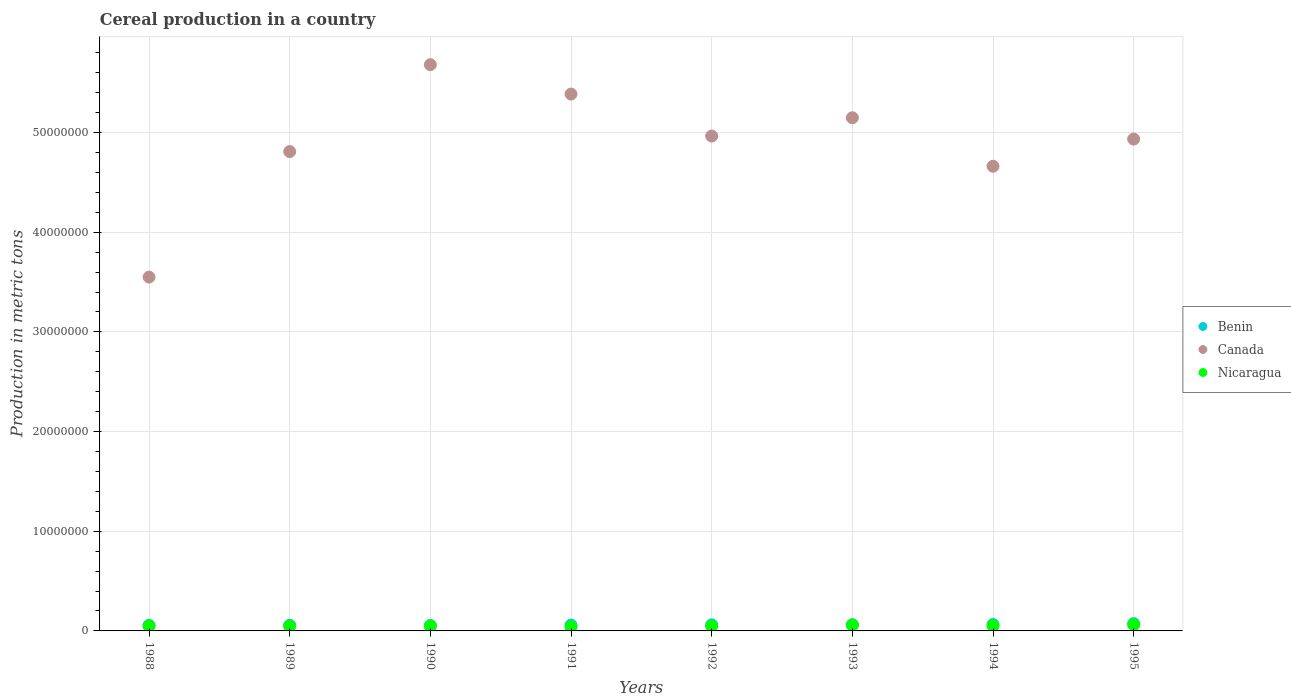How many different coloured dotlines are there?
Provide a short and direct response. 3. Is the number of dotlines equal to the number of legend labels?
Offer a very short reply. Yes. What is the total cereal production in Benin in 1994?
Keep it short and to the point. 6.45e+05. Across all years, what is the maximum total cereal production in Nicaragua?
Your response must be concise. 6.22e+05. Across all years, what is the minimum total cereal production in Benin?
Ensure brevity in your answer.  5.46e+05. In which year was the total cereal production in Benin maximum?
Ensure brevity in your answer.  1995. What is the total total cereal production in Canada in the graph?
Your answer should be compact. 3.91e+08. What is the difference between the total cereal production in Canada in 1990 and that in 1991?
Provide a succinct answer. 2.95e+06. What is the difference between the total cereal production in Nicaragua in 1988 and the total cereal production in Benin in 1995?
Ensure brevity in your answer.  -2.29e+05. What is the average total cereal production in Nicaragua per year?
Your answer should be very brief. 5.13e+05. In the year 1992, what is the difference between the total cereal production in Canada and total cereal production in Nicaragua?
Offer a very short reply. 4.91e+07. In how many years, is the total cereal production in Canada greater than 34000000 metric tons?
Your answer should be compact. 8. What is the ratio of the total cereal production in Canada in 1988 to that in 1995?
Offer a very short reply. 0.72. Is the total cereal production in Nicaragua in 1988 less than that in 1992?
Keep it short and to the point. No. What is the difference between the highest and the second highest total cereal production in Canada?
Ensure brevity in your answer.  2.95e+06. What is the difference between the highest and the lowest total cereal production in Benin?
Keep it short and to the point. 1.88e+05. In how many years, is the total cereal production in Benin greater than the average total cereal production in Benin taken over all years?
Provide a succinct answer. 4. Is it the case that in every year, the sum of the total cereal production in Nicaragua and total cereal production in Benin  is greater than the total cereal production in Canada?
Offer a very short reply. No. Is the total cereal production in Canada strictly less than the total cereal production in Benin over the years?
Offer a very short reply. No. Are the values on the major ticks of Y-axis written in scientific E-notation?
Make the answer very short. No. Does the graph contain grids?
Ensure brevity in your answer.  Yes. How are the legend labels stacked?
Your answer should be compact. Vertical. What is the title of the graph?
Your answer should be very brief. Cereal production in a country. What is the label or title of the X-axis?
Your response must be concise. Years. What is the label or title of the Y-axis?
Provide a succinct answer. Production in metric tons. What is the Production in metric tons in Benin in 1988?
Make the answer very short. 5.57e+05. What is the Production in metric tons of Canada in 1988?
Your answer should be very brief. 3.55e+07. What is the Production in metric tons in Nicaragua in 1988?
Offer a terse response. 5.06e+05. What is the Production in metric tons in Benin in 1989?
Offer a terse response. 5.65e+05. What is the Production in metric tons in Canada in 1989?
Your response must be concise. 4.81e+07. What is the Production in metric tons in Nicaragua in 1989?
Your answer should be very brief. 4.84e+05. What is the Production in metric tons in Benin in 1990?
Offer a terse response. 5.46e+05. What is the Production in metric tons in Canada in 1990?
Ensure brevity in your answer.  5.68e+07. What is the Production in metric tons of Nicaragua in 1990?
Offer a very short reply. 4.88e+05. What is the Production in metric tons in Benin in 1991?
Offer a terse response. 5.87e+05. What is the Production in metric tons of Canada in 1991?
Your answer should be very brief. 5.39e+07. What is the Production in metric tons in Nicaragua in 1991?
Make the answer very short. 4.01e+05. What is the Production in metric tons in Benin in 1992?
Make the answer very short. 6.09e+05. What is the Production in metric tons in Canada in 1992?
Keep it short and to the point. 4.96e+07. What is the Production in metric tons of Nicaragua in 1992?
Provide a succinct answer. 4.98e+05. What is the Production in metric tons of Benin in 1993?
Your answer should be very brief. 6.25e+05. What is the Production in metric tons of Canada in 1993?
Make the answer very short. 5.15e+07. What is the Production in metric tons in Nicaragua in 1993?
Ensure brevity in your answer.  5.88e+05. What is the Production in metric tons of Benin in 1994?
Keep it short and to the point. 6.45e+05. What is the Production in metric tons in Canada in 1994?
Your response must be concise. 4.66e+07. What is the Production in metric tons of Nicaragua in 1994?
Your response must be concise. 5.21e+05. What is the Production in metric tons in Benin in 1995?
Your answer should be very brief. 7.34e+05. What is the Production in metric tons in Canada in 1995?
Provide a short and direct response. 4.93e+07. What is the Production in metric tons in Nicaragua in 1995?
Provide a succinct answer. 6.22e+05. Across all years, what is the maximum Production in metric tons of Benin?
Your response must be concise. 7.34e+05. Across all years, what is the maximum Production in metric tons of Canada?
Your answer should be compact. 5.68e+07. Across all years, what is the maximum Production in metric tons of Nicaragua?
Offer a very short reply. 6.22e+05. Across all years, what is the minimum Production in metric tons in Benin?
Your answer should be very brief. 5.46e+05. Across all years, what is the minimum Production in metric tons in Canada?
Your answer should be compact. 3.55e+07. Across all years, what is the minimum Production in metric tons of Nicaragua?
Your answer should be compact. 4.01e+05. What is the total Production in metric tons of Benin in the graph?
Make the answer very short. 4.87e+06. What is the total Production in metric tons of Canada in the graph?
Ensure brevity in your answer.  3.91e+08. What is the total Production in metric tons in Nicaragua in the graph?
Keep it short and to the point. 4.11e+06. What is the difference between the Production in metric tons of Benin in 1988 and that in 1989?
Offer a terse response. -8036. What is the difference between the Production in metric tons of Canada in 1988 and that in 1989?
Offer a very short reply. -1.26e+07. What is the difference between the Production in metric tons of Nicaragua in 1988 and that in 1989?
Keep it short and to the point. 2.16e+04. What is the difference between the Production in metric tons in Benin in 1988 and that in 1990?
Keep it short and to the point. 1.11e+04. What is the difference between the Production in metric tons of Canada in 1988 and that in 1990?
Provide a succinct answer. -2.13e+07. What is the difference between the Production in metric tons of Nicaragua in 1988 and that in 1990?
Keep it short and to the point. 1.78e+04. What is the difference between the Production in metric tons of Benin in 1988 and that in 1991?
Provide a succinct answer. -3.04e+04. What is the difference between the Production in metric tons of Canada in 1988 and that in 1991?
Make the answer very short. -1.84e+07. What is the difference between the Production in metric tons in Nicaragua in 1988 and that in 1991?
Offer a very short reply. 1.05e+05. What is the difference between the Production in metric tons in Benin in 1988 and that in 1992?
Ensure brevity in your answer.  -5.25e+04. What is the difference between the Production in metric tons in Canada in 1988 and that in 1992?
Ensure brevity in your answer.  -1.42e+07. What is the difference between the Production in metric tons of Nicaragua in 1988 and that in 1992?
Keep it short and to the point. 7410. What is the difference between the Production in metric tons of Benin in 1988 and that in 1993?
Provide a short and direct response. -6.83e+04. What is the difference between the Production in metric tons of Canada in 1988 and that in 1993?
Ensure brevity in your answer.  -1.60e+07. What is the difference between the Production in metric tons of Nicaragua in 1988 and that in 1993?
Your answer should be compact. -8.21e+04. What is the difference between the Production in metric tons in Benin in 1988 and that in 1994?
Offer a very short reply. -8.84e+04. What is the difference between the Production in metric tons in Canada in 1988 and that in 1994?
Offer a very short reply. -1.11e+07. What is the difference between the Production in metric tons of Nicaragua in 1988 and that in 1994?
Your response must be concise. -1.55e+04. What is the difference between the Production in metric tons in Benin in 1988 and that in 1995?
Your answer should be compact. -1.77e+05. What is the difference between the Production in metric tons of Canada in 1988 and that in 1995?
Offer a very short reply. -1.38e+07. What is the difference between the Production in metric tons in Nicaragua in 1988 and that in 1995?
Your answer should be compact. -1.16e+05. What is the difference between the Production in metric tons in Benin in 1989 and that in 1990?
Make the answer very short. 1.91e+04. What is the difference between the Production in metric tons of Canada in 1989 and that in 1990?
Your answer should be very brief. -8.72e+06. What is the difference between the Production in metric tons in Nicaragua in 1989 and that in 1990?
Your response must be concise. -3846. What is the difference between the Production in metric tons of Benin in 1989 and that in 1991?
Provide a short and direct response. -2.23e+04. What is the difference between the Production in metric tons of Canada in 1989 and that in 1991?
Keep it short and to the point. -5.77e+06. What is the difference between the Production in metric tons of Nicaragua in 1989 and that in 1991?
Provide a short and direct response. 8.34e+04. What is the difference between the Production in metric tons of Benin in 1989 and that in 1992?
Your answer should be compact. -4.45e+04. What is the difference between the Production in metric tons of Canada in 1989 and that in 1992?
Provide a short and direct response. -1.56e+06. What is the difference between the Production in metric tons in Nicaragua in 1989 and that in 1992?
Give a very brief answer. -1.42e+04. What is the difference between the Production in metric tons of Benin in 1989 and that in 1993?
Keep it short and to the point. -6.02e+04. What is the difference between the Production in metric tons in Canada in 1989 and that in 1993?
Your answer should be compact. -3.39e+06. What is the difference between the Production in metric tons of Nicaragua in 1989 and that in 1993?
Your answer should be very brief. -1.04e+05. What is the difference between the Production in metric tons in Benin in 1989 and that in 1994?
Your answer should be compact. -8.03e+04. What is the difference between the Production in metric tons of Canada in 1989 and that in 1994?
Keep it short and to the point. 1.47e+06. What is the difference between the Production in metric tons in Nicaragua in 1989 and that in 1994?
Provide a succinct answer. -3.71e+04. What is the difference between the Production in metric tons in Benin in 1989 and that in 1995?
Your answer should be very brief. -1.69e+05. What is the difference between the Production in metric tons in Canada in 1989 and that in 1995?
Provide a short and direct response. -1.25e+06. What is the difference between the Production in metric tons in Nicaragua in 1989 and that in 1995?
Make the answer very short. -1.38e+05. What is the difference between the Production in metric tons of Benin in 1990 and that in 1991?
Offer a very short reply. -4.14e+04. What is the difference between the Production in metric tons of Canada in 1990 and that in 1991?
Keep it short and to the point. 2.95e+06. What is the difference between the Production in metric tons in Nicaragua in 1990 and that in 1991?
Offer a very short reply. 8.72e+04. What is the difference between the Production in metric tons in Benin in 1990 and that in 1992?
Provide a succinct answer. -6.36e+04. What is the difference between the Production in metric tons of Canada in 1990 and that in 1992?
Keep it short and to the point. 7.16e+06. What is the difference between the Production in metric tons in Nicaragua in 1990 and that in 1992?
Make the answer very short. -1.04e+04. What is the difference between the Production in metric tons of Benin in 1990 and that in 1993?
Your answer should be compact. -7.94e+04. What is the difference between the Production in metric tons of Canada in 1990 and that in 1993?
Your response must be concise. 5.32e+06. What is the difference between the Production in metric tons of Nicaragua in 1990 and that in 1993?
Provide a succinct answer. -9.99e+04. What is the difference between the Production in metric tons in Benin in 1990 and that in 1994?
Your answer should be compact. -9.95e+04. What is the difference between the Production in metric tons of Canada in 1990 and that in 1994?
Keep it short and to the point. 1.02e+07. What is the difference between the Production in metric tons of Nicaragua in 1990 and that in 1994?
Provide a succinct answer. -3.33e+04. What is the difference between the Production in metric tons of Benin in 1990 and that in 1995?
Provide a succinct answer. -1.88e+05. What is the difference between the Production in metric tons in Canada in 1990 and that in 1995?
Your answer should be very brief. 7.46e+06. What is the difference between the Production in metric tons of Nicaragua in 1990 and that in 1995?
Offer a terse response. -1.34e+05. What is the difference between the Production in metric tons in Benin in 1991 and that in 1992?
Ensure brevity in your answer.  -2.22e+04. What is the difference between the Production in metric tons in Canada in 1991 and that in 1992?
Your answer should be compact. 4.21e+06. What is the difference between the Production in metric tons of Nicaragua in 1991 and that in 1992?
Your response must be concise. -9.76e+04. What is the difference between the Production in metric tons of Benin in 1991 and that in 1993?
Your answer should be very brief. -3.79e+04. What is the difference between the Production in metric tons of Canada in 1991 and that in 1993?
Make the answer very short. 2.37e+06. What is the difference between the Production in metric tons in Nicaragua in 1991 and that in 1993?
Your response must be concise. -1.87e+05. What is the difference between the Production in metric tons in Benin in 1991 and that in 1994?
Ensure brevity in your answer.  -5.80e+04. What is the difference between the Production in metric tons of Canada in 1991 and that in 1994?
Your answer should be compact. 7.24e+06. What is the difference between the Production in metric tons of Nicaragua in 1991 and that in 1994?
Give a very brief answer. -1.21e+05. What is the difference between the Production in metric tons of Benin in 1991 and that in 1995?
Provide a succinct answer. -1.47e+05. What is the difference between the Production in metric tons in Canada in 1991 and that in 1995?
Your answer should be very brief. 4.51e+06. What is the difference between the Production in metric tons in Nicaragua in 1991 and that in 1995?
Your response must be concise. -2.21e+05. What is the difference between the Production in metric tons of Benin in 1992 and that in 1993?
Provide a succinct answer. -1.58e+04. What is the difference between the Production in metric tons of Canada in 1992 and that in 1993?
Ensure brevity in your answer.  -1.84e+06. What is the difference between the Production in metric tons of Nicaragua in 1992 and that in 1993?
Give a very brief answer. -8.95e+04. What is the difference between the Production in metric tons of Benin in 1992 and that in 1994?
Offer a terse response. -3.59e+04. What is the difference between the Production in metric tons of Canada in 1992 and that in 1994?
Keep it short and to the point. 3.03e+06. What is the difference between the Production in metric tons in Nicaragua in 1992 and that in 1994?
Give a very brief answer. -2.29e+04. What is the difference between the Production in metric tons in Benin in 1992 and that in 1995?
Your response must be concise. -1.25e+05. What is the difference between the Production in metric tons in Canada in 1992 and that in 1995?
Make the answer very short. 3.03e+05. What is the difference between the Production in metric tons of Nicaragua in 1992 and that in 1995?
Make the answer very short. -1.23e+05. What is the difference between the Production in metric tons of Benin in 1993 and that in 1994?
Provide a short and direct response. -2.01e+04. What is the difference between the Production in metric tons of Canada in 1993 and that in 1994?
Your response must be concise. 4.87e+06. What is the difference between the Production in metric tons in Nicaragua in 1993 and that in 1994?
Make the answer very short. 6.66e+04. What is the difference between the Production in metric tons of Benin in 1993 and that in 1995?
Provide a succinct answer. -1.09e+05. What is the difference between the Production in metric tons in Canada in 1993 and that in 1995?
Your answer should be compact. 2.14e+06. What is the difference between the Production in metric tons in Nicaragua in 1993 and that in 1995?
Your answer should be very brief. -3.38e+04. What is the difference between the Production in metric tons in Benin in 1994 and that in 1995?
Your response must be concise. -8.90e+04. What is the difference between the Production in metric tons in Canada in 1994 and that in 1995?
Your response must be concise. -2.73e+06. What is the difference between the Production in metric tons in Nicaragua in 1994 and that in 1995?
Ensure brevity in your answer.  -1.00e+05. What is the difference between the Production in metric tons of Benin in 1988 and the Production in metric tons of Canada in 1989?
Your response must be concise. -4.75e+07. What is the difference between the Production in metric tons in Benin in 1988 and the Production in metric tons in Nicaragua in 1989?
Ensure brevity in your answer.  7.30e+04. What is the difference between the Production in metric tons in Canada in 1988 and the Production in metric tons in Nicaragua in 1989?
Your response must be concise. 3.50e+07. What is the difference between the Production in metric tons of Benin in 1988 and the Production in metric tons of Canada in 1990?
Ensure brevity in your answer.  -5.62e+07. What is the difference between the Production in metric tons in Benin in 1988 and the Production in metric tons in Nicaragua in 1990?
Your answer should be compact. 6.92e+04. What is the difference between the Production in metric tons in Canada in 1988 and the Production in metric tons in Nicaragua in 1990?
Offer a terse response. 3.50e+07. What is the difference between the Production in metric tons in Benin in 1988 and the Production in metric tons in Canada in 1991?
Provide a succinct answer. -5.33e+07. What is the difference between the Production in metric tons in Benin in 1988 and the Production in metric tons in Nicaragua in 1991?
Offer a terse response. 1.56e+05. What is the difference between the Production in metric tons in Canada in 1988 and the Production in metric tons in Nicaragua in 1991?
Your answer should be very brief. 3.51e+07. What is the difference between the Production in metric tons in Benin in 1988 and the Production in metric tons in Canada in 1992?
Provide a succinct answer. -4.91e+07. What is the difference between the Production in metric tons of Benin in 1988 and the Production in metric tons of Nicaragua in 1992?
Ensure brevity in your answer.  5.88e+04. What is the difference between the Production in metric tons of Canada in 1988 and the Production in metric tons of Nicaragua in 1992?
Keep it short and to the point. 3.50e+07. What is the difference between the Production in metric tons in Benin in 1988 and the Production in metric tons in Canada in 1993?
Your answer should be compact. -5.09e+07. What is the difference between the Production in metric tons in Benin in 1988 and the Production in metric tons in Nicaragua in 1993?
Ensure brevity in your answer.  -3.07e+04. What is the difference between the Production in metric tons in Canada in 1988 and the Production in metric tons in Nicaragua in 1993?
Provide a short and direct response. 3.49e+07. What is the difference between the Production in metric tons of Benin in 1988 and the Production in metric tons of Canada in 1994?
Provide a succinct answer. -4.61e+07. What is the difference between the Production in metric tons in Benin in 1988 and the Production in metric tons in Nicaragua in 1994?
Give a very brief answer. 3.59e+04. What is the difference between the Production in metric tons of Canada in 1988 and the Production in metric tons of Nicaragua in 1994?
Provide a short and direct response. 3.50e+07. What is the difference between the Production in metric tons of Benin in 1988 and the Production in metric tons of Canada in 1995?
Your answer should be compact. -4.88e+07. What is the difference between the Production in metric tons of Benin in 1988 and the Production in metric tons of Nicaragua in 1995?
Give a very brief answer. -6.46e+04. What is the difference between the Production in metric tons in Canada in 1988 and the Production in metric tons in Nicaragua in 1995?
Make the answer very short. 3.49e+07. What is the difference between the Production in metric tons of Benin in 1989 and the Production in metric tons of Canada in 1990?
Make the answer very short. -5.62e+07. What is the difference between the Production in metric tons in Benin in 1989 and the Production in metric tons in Nicaragua in 1990?
Offer a terse response. 7.72e+04. What is the difference between the Production in metric tons in Canada in 1989 and the Production in metric tons in Nicaragua in 1990?
Your response must be concise. 4.76e+07. What is the difference between the Production in metric tons of Benin in 1989 and the Production in metric tons of Canada in 1991?
Ensure brevity in your answer.  -5.33e+07. What is the difference between the Production in metric tons of Benin in 1989 and the Production in metric tons of Nicaragua in 1991?
Give a very brief answer. 1.64e+05. What is the difference between the Production in metric tons of Canada in 1989 and the Production in metric tons of Nicaragua in 1991?
Your answer should be very brief. 4.77e+07. What is the difference between the Production in metric tons of Benin in 1989 and the Production in metric tons of Canada in 1992?
Provide a succinct answer. -4.91e+07. What is the difference between the Production in metric tons of Benin in 1989 and the Production in metric tons of Nicaragua in 1992?
Your response must be concise. 6.68e+04. What is the difference between the Production in metric tons of Canada in 1989 and the Production in metric tons of Nicaragua in 1992?
Your response must be concise. 4.76e+07. What is the difference between the Production in metric tons in Benin in 1989 and the Production in metric tons in Canada in 1993?
Provide a short and direct response. -5.09e+07. What is the difference between the Production in metric tons in Benin in 1989 and the Production in metric tons in Nicaragua in 1993?
Ensure brevity in your answer.  -2.27e+04. What is the difference between the Production in metric tons in Canada in 1989 and the Production in metric tons in Nicaragua in 1993?
Offer a very short reply. 4.75e+07. What is the difference between the Production in metric tons of Benin in 1989 and the Production in metric tons of Canada in 1994?
Offer a very short reply. -4.61e+07. What is the difference between the Production in metric tons in Benin in 1989 and the Production in metric tons in Nicaragua in 1994?
Provide a succinct answer. 4.39e+04. What is the difference between the Production in metric tons in Canada in 1989 and the Production in metric tons in Nicaragua in 1994?
Offer a terse response. 4.76e+07. What is the difference between the Production in metric tons in Benin in 1989 and the Production in metric tons in Canada in 1995?
Offer a terse response. -4.88e+07. What is the difference between the Production in metric tons of Benin in 1989 and the Production in metric tons of Nicaragua in 1995?
Ensure brevity in your answer.  -5.65e+04. What is the difference between the Production in metric tons in Canada in 1989 and the Production in metric tons in Nicaragua in 1995?
Keep it short and to the point. 4.75e+07. What is the difference between the Production in metric tons of Benin in 1990 and the Production in metric tons of Canada in 1991?
Your answer should be compact. -5.33e+07. What is the difference between the Production in metric tons in Benin in 1990 and the Production in metric tons in Nicaragua in 1991?
Offer a very short reply. 1.45e+05. What is the difference between the Production in metric tons in Canada in 1990 and the Production in metric tons in Nicaragua in 1991?
Your answer should be very brief. 5.64e+07. What is the difference between the Production in metric tons in Benin in 1990 and the Production in metric tons in Canada in 1992?
Ensure brevity in your answer.  -4.91e+07. What is the difference between the Production in metric tons in Benin in 1990 and the Production in metric tons in Nicaragua in 1992?
Offer a very short reply. 4.77e+04. What is the difference between the Production in metric tons in Canada in 1990 and the Production in metric tons in Nicaragua in 1992?
Make the answer very short. 5.63e+07. What is the difference between the Production in metric tons of Benin in 1990 and the Production in metric tons of Canada in 1993?
Provide a short and direct response. -5.09e+07. What is the difference between the Production in metric tons in Benin in 1990 and the Production in metric tons in Nicaragua in 1993?
Offer a terse response. -4.18e+04. What is the difference between the Production in metric tons of Canada in 1990 and the Production in metric tons of Nicaragua in 1993?
Your answer should be compact. 5.62e+07. What is the difference between the Production in metric tons in Benin in 1990 and the Production in metric tons in Canada in 1994?
Give a very brief answer. -4.61e+07. What is the difference between the Production in metric tons in Benin in 1990 and the Production in metric tons in Nicaragua in 1994?
Provide a short and direct response. 2.48e+04. What is the difference between the Production in metric tons in Canada in 1990 and the Production in metric tons in Nicaragua in 1994?
Offer a very short reply. 5.63e+07. What is the difference between the Production in metric tons of Benin in 1990 and the Production in metric tons of Canada in 1995?
Keep it short and to the point. -4.88e+07. What is the difference between the Production in metric tons in Benin in 1990 and the Production in metric tons in Nicaragua in 1995?
Provide a succinct answer. -7.56e+04. What is the difference between the Production in metric tons of Canada in 1990 and the Production in metric tons of Nicaragua in 1995?
Your response must be concise. 5.62e+07. What is the difference between the Production in metric tons in Benin in 1991 and the Production in metric tons in Canada in 1992?
Provide a short and direct response. -4.91e+07. What is the difference between the Production in metric tons in Benin in 1991 and the Production in metric tons in Nicaragua in 1992?
Your answer should be compact. 8.92e+04. What is the difference between the Production in metric tons in Canada in 1991 and the Production in metric tons in Nicaragua in 1992?
Give a very brief answer. 5.34e+07. What is the difference between the Production in metric tons of Benin in 1991 and the Production in metric tons of Canada in 1993?
Offer a terse response. -5.09e+07. What is the difference between the Production in metric tons in Benin in 1991 and the Production in metric tons in Nicaragua in 1993?
Your response must be concise. -371. What is the difference between the Production in metric tons of Canada in 1991 and the Production in metric tons of Nicaragua in 1993?
Make the answer very short. 5.33e+07. What is the difference between the Production in metric tons of Benin in 1991 and the Production in metric tons of Canada in 1994?
Your answer should be compact. -4.60e+07. What is the difference between the Production in metric tons of Benin in 1991 and the Production in metric tons of Nicaragua in 1994?
Give a very brief answer. 6.62e+04. What is the difference between the Production in metric tons of Canada in 1991 and the Production in metric tons of Nicaragua in 1994?
Offer a very short reply. 5.33e+07. What is the difference between the Production in metric tons of Benin in 1991 and the Production in metric tons of Canada in 1995?
Your response must be concise. -4.88e+07. What is the difference between the Production in metric tons of Benin in 1991 and the Production in metric tons of Nicaragua in 1995?
Give a very brief answer. -3.42e+04. What is the difference between the Production in metric tons in Canada in 1991 and the Production in metric tons in Nicaragua in 1995?
Your answer should be compact. 5.32e+07. What is the difference between the Production in metric tons in Benin in 1992 and the Production in metric tons in Canada in 1993?
Offer a very short reply. -5.09e+07. What is the difference between the Production in metric tons in Benin in 1992 and the Production in metric tons in Nicaragua in 1993?
Provide a short and direct response. 2.18e+04. What is the difference between the Production in metric tons in Canada in 1992 and the Production in metric tons in Nicaragua in 1993?
Provide a succinct answer. 4.91e+07. What is the difference between the Production in metric tons in Benin in 1992 and the Production in metric tons in Canada in 1994?
Provide a succinct answer. -4.60e+07. What is the difference between the Production in metric tons in Benin in 1992 and the Production in metric tons in Nicaragua in 1994?
Make the answer very short. 8.84e+04. What is the difference between the Production in metric tons in Canada in 1992 and the Production in metric tons in Nicaragua in 1994?
Your answer should be compact. 4.91e+07. What is the difference between the Production in metric tons in Benin in 1992 and the Production in metric tons in Canada in 1995?
Provide a succinct answer. -4.87e+07. What is the difference between the Production in metric tons of Benin in 1992 and the Production in metric tons of Nicaragua in 1995?
Provide a succinct answer. -1.20e+04. What is the difference between the Production in metric tons of Canada in 1992 and the Production in metric tons of Nicaragua in 1995?
Make the answer very short. 4.90e+07. What is the difference between the Production in metric tons of Benin in 1993 and the Production in metric tons of Canada in 1994?
Make the answer very short. -4.60e+07. What is the difference between the Production in metric tons in Benin in 1993 and the Production in metric tons in Nicaragua in 1994?
Make the answer very short. 1.04e+05. What is the difference between the Production in metric tons in Canada in 1993 and the Production in metric tons in Nicaragua in 1994?
Your answer should be very brief. 5.10e+07. What is the difference between the Production in metric tons of Benin in 1993 and the Production in metric tons of Canada in 1995?
Offer a very short reply. -4.87e+07. What is the difference between the Production in metric tons in Benin in 1993 and the Production in metric tons in Nicaragua in 1995?
Keep it short and to the point. 3721. What is the difference between the Production in metric tons of Canada in 1993 and the Production in metric tons of Nicaragua in 1995?
Your response must be concise. 5.09e+07. What is the difference between the Production in metric tons of Benin in 1994 and the Production in metric tons of Canada in 1995?
Your response must be concise. -4.87e+07. What is the difference between the Production in metric tons of Benin in 1994 and the Production in metric tons of Nicaragua in 1995?
Your answer should be very brief. 2.38e+04. What is the difference between the Production in metric tons of Canada in 1994 and the Production in metric tons of Nicaragua in 1995?
Your response must be concise. 4.60e+07. What is the average Production in metric tons of Benin per year?
Give a very brief answer. 6.09e+05. What is the average Production in metric tons in Canada per year?
Provide a succinct answer. 4.89e+07. What is the average Production in metric tons in Nicaragua per year?
Your response must be concise. 5.13e+05. In the year 1988, what is the difference between the Production in metric tons in Benin and Production in metric tons in Canada?
Your answer should be compact. -3.49e+07. In the year 1988, what is the difference between the Production in metric tons of Benin and Production in metric tons of Nicaragua?
Your response must be concise. 5.14e+04. In the year 1988, what is the difference between the Production in metric tons in Canada and Production in metric tons in Nicaragua?
Make the answer very short. 3.50e+07. In the year 1989, what is the difference between the Production in metric tons in Benin and Production in metric tons in Canada?
Your response must be concise. -4.75e+07. In the year 1989, what is the difference between the Production in metric tons in Benin and Production in metric tons in Nicaragua?
Offer a very short reply. 8.11e+04. In the year 1989, what is the difference between the Production in metric tons of Canada and Production in metric tons of Nicaragua?
Your response must be concise. 4.76e+07. In the year 1990, what is the difference between the Production in metric tons of Benin and Production in metric tons of Canada?
Offer a terse response. -5.63e+07. In the year 1990, what is the difference between the Production in metric tons of Benin and Production in metric tons of Nicaragua?
Make the answer very short. 5.81e+04. In the year 1990, what is the difference between the Production in metric tons of Canada and Production in metric tons of Nicaragua?
Give a very brief answer. 5.63e+07. In the year 1991, what is the difference between the Production in metric tons in Benin and Production in metric tons in Canada?
Your answer should be very brief. -5.33e+07. In the year 1991, what is the difference between the Production in metric tons in Benin and Production in metric tons in Nicaragua?
Your response must be concise. 1.87e+05. In the year 1991, what is the difference between the Production in metric tons of Canada and Production in metric tons of Nicaragua?
Offer a very short reply. 5.35e+07. In the year 1992, what is the difference between the Production in metric tons of Benin and Production in metric tons of Canada?
Make the answer very short. -4.90e+07. In the year 1992, what is the difference between the Production in metric tons in Benin and Production in metric tons in Nicaragua?
Ensure brevity in your answer.  1.11e+05. In the year 1992, what is the difference between the Production in metric tons in Canada and Production in metric tons in Nicaragua?
Give a very brief answer. 4.91e+07. In the year 1993, what is the difference between the Production in metric tons in Benin and Production in metric tons in Canada?
Your answer should be compact. -5.09e+07. In the year 1993, what is the difference between the Production in metric tons of Benin and Production in metric tons of Nicaragua?
Your answer should be very brief. 3.75e+04. In the year 1993, what is the difference between the Production in metric tons of Canada and Production in metric tons of Nicaragua?
Your answer should be compact. 5.09e+07. In the year 1994, what is the difference between the Production in metric tons of Benin and Production in metric tons of Canada?
Make the answer very short. -4.60e+07. In the year 1994, what is the difference between the Production in metric tons in Benin and Production in metric tons in Nicaragua?
Your response must be concise. 1.24e+05. In the year 1994, what is the difference between the Production in metric tons of Canada and Production in metric tons of Nicaragua?
Your answer should be compact. 4.61e+07. In the year 1995, what is the difference between the Production in metric tons in Benin and Production in metric tons in Canada?
Offer a terse response. -4.86e+07. In the year 1995, what is the difference between the Production in metric tons in Benin and Production in metric tons in Nicaragua?
Offer a very short reply. 1.13e+05. In the year 1995, what is the difference between the Production in metric tons of Canada and Production in metric tons of Nicaragua?
Your response must be concise. 4.87e+07. What is the ratio of the Production in metric tons in Benin in 1988 to that in 1989?
Give a very brief answer. 0.99. What is the ratio of the Production in metric tons of Canada in 1988 to that in 1989?
Provide a succinct answer. 0.74. What is the ratio of the Production in metric tons in Nicaragua in 1988 to that in 1989?
Your response must be concise. 1.04. What is the ratio of the Production in metric tons of Benin in 1988 to that in 1990?
Your answer should be very brief. 1.02. What is the ratio of the Production in metric tons in Canada in 1988 to that in 1990?
Your response must be concise. 0.62. What is the ratio of the Production in metric tons of Nicaragua in 1988 to that in 1990?
Provide a succinct answer. 1.04. What is the ratio of the Production in metric tons in Benin in 1988 to that in 1991?
Ensure brevity in your answer.  0.95. What is the ratio of the Production in metric tons of Canada in 1988 to that in 1991?
Keep it short and to the point. 0.66. What is the ratio of the Production in metric tons of Nicaragua in 1988 to that in 1991?
Keep it short and to the point. 1.26. What is the ratio of the Production in metric tons in Benin in 1988 to that in 1992?
Provide a short and direct response. 0.91. What is the ratio of the Production in metric tons of Canada in 1988 to that in 1992?
Offer a terse response. 0.71. What is the ratio of the Production in metric tons of Nicaragua in 1988 to that in 1992?
Make the answer very short. 1.01. What is the ratio of the Production in metric tons in Benin in 1988 to that in 1993?
Your answer should be compact. 0.89. What is the ratio of the Production in metric tons in Canada in 1988 to that in 1993?
Give a very brief answer. 0.69. What is the ratio of the Production in metric tons of Nicaragua in 1988 to that in 1993?
Offer a terse response. 0.86. What is the ratio of the Production in metric tons in Benin in 1988 to that in 1994?
Offer a terse response. 0.86. What is the ratio of the Production in metric tons in Canada in 1988 to that in 1994?
Your answer should be compact. 0.76. What is the ratio of the Production in metric tons in Nicaragua in 1988 to that in 1994?
Your response must be concise. 0.97. What is the ratio of the Production in metric tons in Benin in 1988 to that in 1995?
Ensure brevity in your answer.  0.76. What is the ratio of the Production in metric tons in Canada in 1988 to that in 1995?
Make the answer very short. 0.72. What is the ratio of the Production in metric tons in Nicaragua in 1988 to that in 1995?
Make the answer very short. 0.81. What is the ratio of the Production in metric tons of Benin in 1989 to that in 1990?
Give a very brief answer. 1.03. What is the ratio of the Production in metric tons of Canada in 1989 to that in 1990?
Your answer should be very brief. 0.85. What is the ratio of the Production in metric tons in Nicaragua in 1989 to that in 1990?
Your answer should be compact. 0.99. What is the ratio of the Production in metric tons in Canada in 1989 to that in 1991?
Offer a terse response. 0.89. What is the ratio of the Production in metric tons of Nicaragua in 1989 to that in 1991?
Keep it short and to the point. 1.21. What is the ratio of the Production in metric tons in Benin in 1989 to that in 1992?
Your answer should be very brief. 0.93. What is the ratio of the Production in metric tons in Canada in 1989 to that in 1992?
Ensure brevity in your answer.  0.97. What is the ratio of the Production in metric tons in Nicaragua in 1989 to that in 1992?
Your answer should be compact. 0.97. What is the ratio of the Production in metric tons in Benin in 1989 to that in 1993?
Offer a terse response. 0.9. What is the ratio of the Production in metric tons of Canada in 1989 to that in 1993?
Provide a short and direct response. 0.93. What is the ratio of the Production in metric tons in Nicaragua in 1989 to that in 1993?
Provide a short and direct response. 0.82. What is the ratio of the Production in metric tons of Benin in 1989 to that in 1994?
Your response must be concise. 0.88. What is the ratio of the Production in metric tons of Canada in 1989 to that in 1994?
Ensure brevity in your answer.  1.03. What is the ratio of the Production in metric tons in Nicaragua in 1989 to that in 1994?
Give a very brief answer. 0.93. What is the ratio of the Production in metric tons in Benin in 1989 to that in 1995?
Provide a succinct answer. 0.77. What is the ratio of the Production in metric tons in Canada in 1989 to that in 1995?
Your answer should be compact. 0.97. What is the ratio of the Production in metric tons in Nicaragua in 1989 to that in 1995?
Offer a very short reply. 0.78. What is the ratio of the Production in metric tons in Benin in 1990 to that in 1991?
Provide a short and direct response. 0.93. What is the ratio of the Production in metric tons of Canada in 1990 to that in 1991?
Ensure brevity in your answer.  1.05. What is the ratio of the Production in metric tons in Nicaragua in 1990 to that in 1991?
Your answer should be compact. 1.22. What is the ratio of the Production in metric tons of Benin in 1990 to that in 1992?
Ensure brevity in your answer.  0.9. What is the ratio of the Production in metric tons of Canada in 1990 to that in 1992?
Offer a terse response. 1.14. What is the ratio of the Production in metric tons of Nicaragua in 1990 to that in 1992?
Provide a short and direct response. 0.98. What is the ratio of the Production in metric tons in Benin in 1990 to that in 1993?
Your answer should be very brief. 0.87. What is the ratio of the Production in metric tons in Canada in 1990 to that in 1993?
Make the answer very short. 1.1. What is the ratio of the Production in metric tons of Nicaragua in 1990 to that in 1993?
Give a very brief answer. 0.83. What is the ratio of the Production in metric tons in Benin in 1990 to that in 1994?
Provide a short and direct response. 0.85. What is the ratio of the Production in metric tons in Canada in 1990 to that in 1994?
Ensure brevity in your answer.  1.22. What is the ratio of the Production in metric tons in Nicaragua in 1990 to that in 1994?
Offer a very short reply. 0.94. What is the ratio of the Production in metric tons of Benin in 1990 to that in 1995?
Keep it short and to the point. 0.74. What is the ratio of the Production in metric tons in Canada in 1990 to that in 1995?
Your answer should be compact. 1.15. What is the ratio of the Production in metric tons of Nicaragua in 1990 to that in 1995?
Provide a succinct answer. 0.78. What is the ratio of the Production in metric tons in Benin in 1991 to that in 1992?
Give a very brief answer. 0.96. What is the ratio of the Production in metric tons of Canada in 1991 to that in 1992?
Offer a very short reply. 1.08. What is the ratio of the Production in metric tons in Nicaragua in 1991 to that in 1992?
Offer a very short reply. 0.8. What is the ratio of the Production in metric tons of Benin in 1991 to that in 1993?
Keep it short and to the point. 0.94. What is the ratio of the Production in metric tons in Canada in 1991 to that in 1993?
Your response must be concise. 1.05. What is the ratio of the Production in metric tons in Nicaragua in 1991 to that in 1993?
Give a very brief answer. 0.68. What is the ratio of the Production in metric tons of Benin in 1991 to that in 1994?
Keep it short and to the point. 0.91. What is the ratio of the Production in metric tons of Canada in 1991 to that in 1994?
Your answer should be compact. 1.16. What is the ratio of the Production in metric tons of Nicaragua in 1991 to that in 1994?
Give a very brief answer. 0.77. What is the ratio of the Production in metric tons of Benin in 1991 to that in 1995?
Ensure brevity in your answer.  0.8. What is the ratio of the Production in metric tons of Canada in 1991 to that in 1995?
Your response must be concise. 1.09. What is the ratio of the Production in metric tons of Nicaragua in 1991 to that in 1995?
Provide a succinct answer. 0.64. What is the ratio of the Production in metric tons of Benin in 1992 to that in 1993?
Your response must be concise. 0.97. What is the ratio of the Production in metric tons of Nicaragua in 1992 to that in 1993?
Your answer should be very brief. 0.85. What is the ratio of the Production in metric tons of Benin in 1992 to that in 1994?
Make the answer very short. 0.94. What is the ratio of the Production in metric tons in Canada in 1992 to that in 1994?
Offer a terse response. 1.06. What is the ratio of the Production in metric tons of Nicaragua in 1992 to that in 1994?
Make the answer very short. 0.96. What is the ratio of the Production in metric tons of Benin in 1992 to that in 1995?
Provide a succinct answer. 0.83. What is the ratio of the Production in metric tons of Canada in 1992 to that in 1995?
Give a very brief answer. 1.01. What is the ratio of the Production in metric tons in Nicaragua in 1992 to that in 1995?
Offer a terse response. 0.8. What is the ratio of the Production in metric tons of Benin in 1993 to that in 1994?
Your answer should be very brief. 0.97. What is the ratio of the Production in metric tons in Canada in 1993 to that in 1994?
Make the answer very short. 1.1. What is the ratio of the Production in metric tons of Nicaragua in 1993 to that in 1994?
Give a very brief answer. 1.13. What is the ratio of the Production in metric tons of Benin in 1993 to that in 1995?
Offer a terse response. 0.85. What is the ratio of the Production in metric tons in Canada in 1993 to that in 1995?
Give a very brief answer. 1.04. What is the ratio of the Production in metric tons of Nicaragua in 1993 to that in 1995?
Offer a very short reply. 0.95. What is the ratio of the Production in metric tons in Benin in 1994 to that in 1995?
Your answer should be compact. 0.88. What is the ratio of the Production in metric tons in Canada in 1994 to that in 1995?
Ensure brevity in your answer.  0.94. What is the ratio of the Production in metric tons in Nicaragua in 1994 to that in 1995?
Your answer should be very brief. 0.84. What is the difference between the highest and the second highest Production in metric tons in Benin?
Keep it short and to the point. 8.90e+04. What is the difference between the highest and the second highest Production in metric tons of Canada?
Provide a short and direct response. 2.95e+06. What is the difference between the highest and the second highest Production in metric tons in Nicaragua?
Make the answer very short. 3.38e+04. What is the difference between the highest and the lowest Production in metric tons in Benin?
Your answer should be compact. 1.88e+05. What is the difference between the highest and the lowest Production in metric tons in Canada?
Provide a succinct answer. 2.13e+07. What is the difference between the highest and the lowest Production in metric tons in Nicaragua?
Provide a succinct answer. 2.21e+05. 